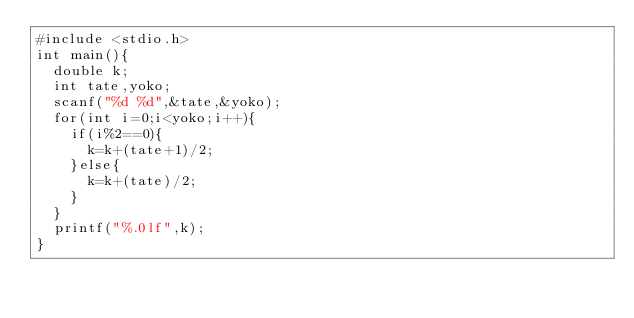<code> <loc_0><loc_0><loc_500><loc_500><_C_>#include <stdio.h>
int main(){
  double k;
  int tate,yoko;
  scanf("%d %d",&tate,&yoko);
  for(int i=0;i<yoko;i++){
    if(i%2==0){
      k=k+(tate+1)/2;
    }else{
      k=k+(tate)/2;
    }
  }
  printf("%.0lf",k);
}</code> 